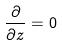<formula> <loc_0><loc_0><loc_500><loc_500>\frac { \partial } { \partial z } = 0</formula> 